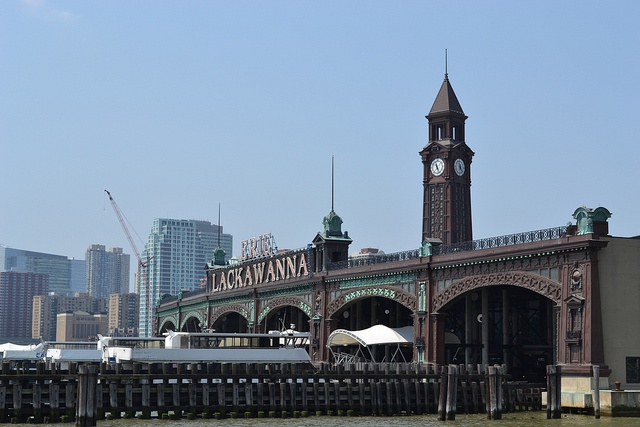Describe the objects in this image and their specific colors. I can see clock in lightblue, lightgray, darkgray, and gray tones and clock in lightblue, gray, and black tones in this image. 